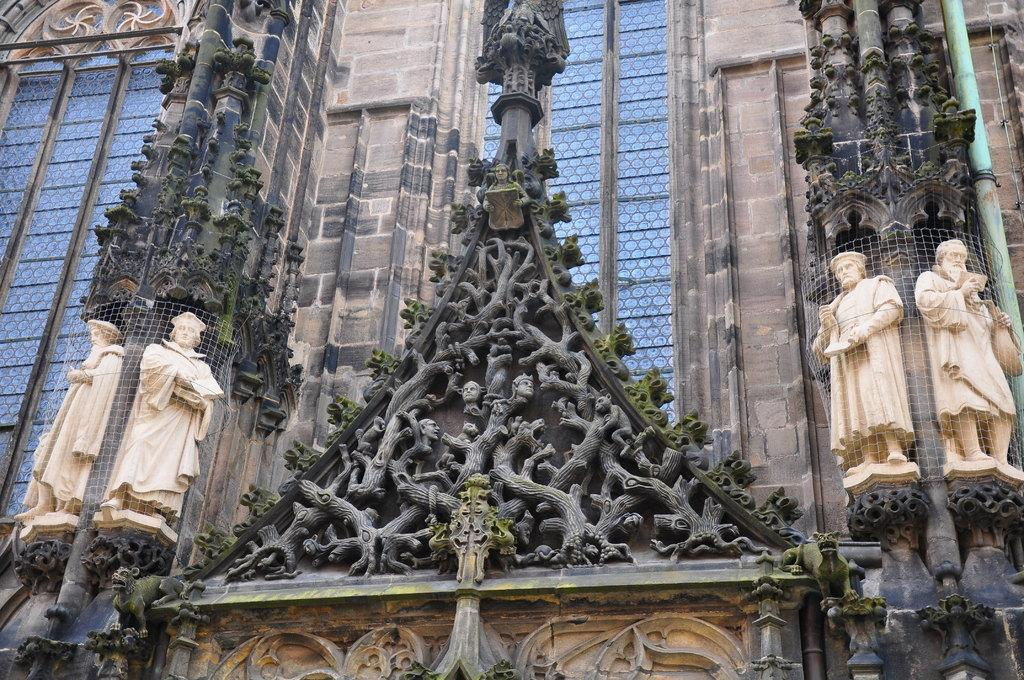What type of structure is visible in the image? There is a building in the image. What feature can be seen on the building? The building has windows. Are there any decorative elements on the building? Yes, there are sculptures on the wall of the building. What type of lamp is hanging from the ceiling in the image? There is no lamp visible in the image; it only features a building with windows and sculptures on the wall. 